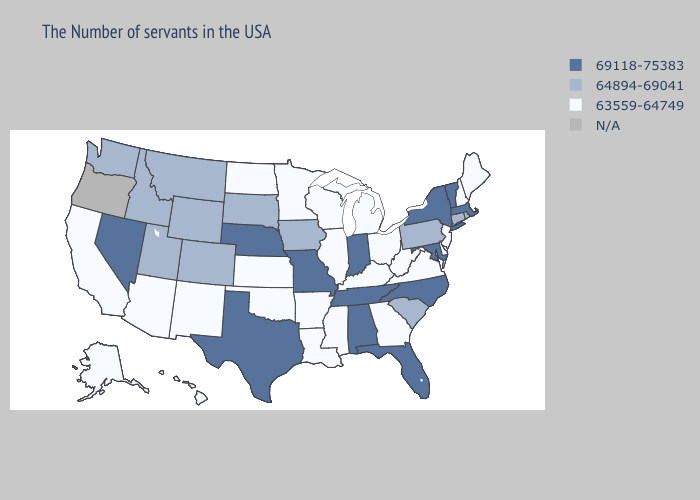Which states hav the highest value in the Northeast?
Concise answer only. Massachusetts, Vermont, New York. Does Pennsylvania have the lowest value in the Northeast?
Concise answer only. No. What is the highest value in the MidWest ?
Be succinct. 69118-75383. Which states have the highest value in the USA?
Keep it brief. Massachusetts, Vermont, New York, Maryland, North Carolina, Florida, Indiana, Alabama, Tennessee, Missouri, Nebraska, Texas, Nevada. What is the highest value in the USA?
Keep it brief. 69118-75383. How many symbols are there in the legend?
Keep it brief. 4. What is the value of Maine?
Give a very brief answer. 63559-64749. What is the value of Utah?
Be succinct. 64894-69041. What is the value of Hawaii?
Quick response, please. 63559-64749. Which states hav the highest value in the MidWest?
Concise answer only. Indiana, Missouri, Nebraska. What is the lowest value in the USA?
Answer briefly. 63559-64749. Does the map have missing data?
Give a very brief answer. Yes. Name the states that have a value in the range N/A?
Give a very brief answer. Oregon. Among the states that border Nevada , does Utah have the lowest value?
Concise answer only. No. Among the states that border Illinois , which have the lowest value?
Be succinct. Kentucky, Wisconsin. 